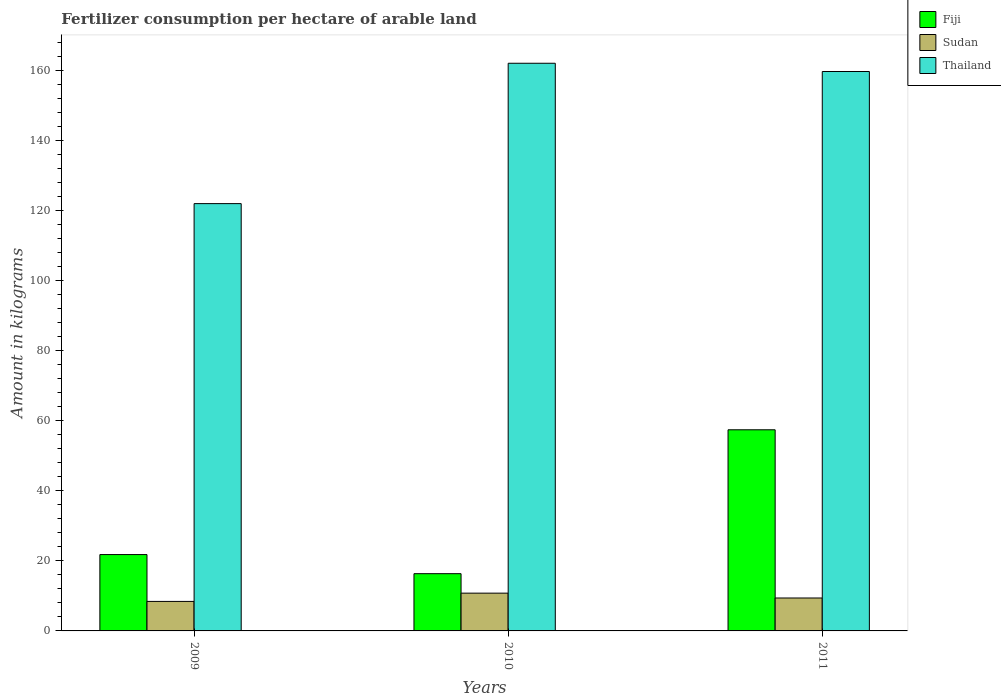How many different coloured bars are there?
Ensure brevity in your answer.  3. How many bars are there on the 3rd tick from the left?
Offer a terse response. 3. How many bars are there on the 3rd tick from the right?
Keep it short and to the point. 3. What is the amount of fertilizer consumption in Thailand in 2009?
Your response must be concise. 122.06. Across all years, what is the maximum amount of fertilizer consumption in Fiji?
Ensure brevity in your answer.  57.45. Across all years, what is the minimum amount of fertilizer consumption in Thailand?
Ensure brevity in your answer.  122.06. In which year was the amount of fertilizer consumption in Sudan minimum?
Give a very brief answer. 2009. What is the total amount of fertilizer consumption in Fiji in the graph?
Provide a succinct answer. 95.61. What is the difference between the amount of fertilizer consumption in Fiji in 2009 and that in 2010?
Offer a very short reply. 5.46. What is the difference between the amount of fertilizer consumption in Thailand in 2011 and the amount of fertilizer consumption in Sudan in 2009?
Offer a very short reply. 151.37. What is the average amount of fertilizer consumption in Thailand per year?
Make the answer very short. 148. In the year 2011, what is the difference between the amount of fertilizer consumption in Fiji and amount of fertilizer consumption in Thailand?
Keep it short and to the point. -102.35. In how many years, is the amount of fertilizer consumption in Fiji greater than 36 kg?
Ensure brevity in your answer.  1. What is the ratio of the amount of fertilizer consumption in Fiji in 2010 to that in 2011?
Give a very brief answer. 0.28. Is the amount of fertilizer consumption in Thailand in 2009 less than that in 2010?
Your answer should be compact. Yes. What is the difference between the highest and the second highest amount of fertilizer consumption in Thailand?
Your response must be concise. 2.36. What is the difference between the highest and the lowest amount of fertilizer consumption in Sudan?
Your answer should be compact. 2.36. What does the 2nd bar from the left in 2010 represents?
Offer a very short reply. Sudan. What does the 2nd bar from the right in 2009 represents?
Offer a terse response. Sudan. How many bars are there?
Your answer should be compact. 9. Are all the bars in the graph horizontal?
Give a very brief answer. No. Are the values on the major ticks of Y-axis written in scientific E-notation?
Offer a very short reply. No. Does the graph contain any zero values?
Make the answer very short. No. Does the graph contain grids?
Provide a short and direct response. No. Where does the legend appear in the graph?
Make the answer very short. Top right. What is the title of the graph?
Offer a very short reply. Fertilizer consumption per hectare of arable land. Does "Azerbaijan" appear as one of the legend labels in the graph?
Ensure brevity in your answer.  No. What is the label or title of the X-axis?
Your answer should be very brief. Years. What is the label or title of the Y-axis?
Ensure brevity in your answer.  Amount in kilograms. What is the Amount in kilograms in Fiji in 2009?
Keep it short and to the point. 21.81. What is the Amount in kilograms in Sudan in 2009?
Ensure brevity in your answer.  8.43. What is the Amount in kilograms in Thailand in 2009?
Provide a succinct answer. 122.06. What is the Amount in kilograms in Fiji in 2010?
Keep it short and to the point. 16.35. What is the Amount in kilograms of Sudan in 2010?
Give a very brief answer. 10.79. What is the Amount in kilograms of Thailand in 2010?
Keep it short and to the point. 162.16. What is the Amount in kilograms of Fiji in 2011?
Offer a very short reply. 57.45. What is the Amount in kilograms in Sudan in 2011?
Give a very brief answer. 9.41. What is the Amount in kilograms of Thailand in 2011?
Make the answer very short. 159.8. Across all years, what is the maximum Amount in kilograms in Fiji?
Provide a short and direct response. 57.45. Across all years, what is the maximum Amount in kilograms of Sudan?
Ensure brevity in your answer.  10.79. Across all years, what is the maximum Amount in kilograms in Thailand?
Your answer should be very brief. 162.16. Across all years, what is the minimum Amount in kilograms of Fiji?
Ensure brevity in your answer.  16.35. Across all years, what is the minimum Amount in kilograms of Sudan?
Keep it short and to the point. 8.43. Across all years, what is the minimum Amount in kilograms of Thailand?
Offer a terse response. 122.06. What is the total Amount in kilograms of Fiji in the graph?
Provide a succinct answer. 95.61. What is the total Amount in kilograms of Sudan in the graph?
Offer a terse response. 28.63. What is the total Amount in kilograms of Thailand in the graph?
Your answer should be very brief. 444.01. What is the difference between the Amount in kilograms in Fiji in 2009 and that in 2010?
Give a very brief answer. 5.46. What is the difference between the Amount in kilograms of Sudan in 2009 and that in 2010?
Keep it short and to the point. -2.36. What is the difference between the Amount in kilograms of Thailand in 2009 and that in 2010?
Give a very brief answer. -40.1. What is the difference between the Amount in kilograms in Fiji in 2009 and that in 2011?
Ensure brevity in your answer.  -35.65. What is the difference between the Amount in kilograms of Sudan in 2009 and that in 2011?
Keep it short and to the point. -0.98. What is the difference between the Amount in kilograms of Thailand in 2009 and that in 2011?
Give a very brief answer. -37.74. What is the difference between the Amount in kilograms in Fiji in 2010 and that in 2011?
Ensure brevity in your answer.  -41.1. What is the difference between the Amount in kilograms of Sudan in 2010 and that in 2011?
Offer a terse response. 1.38. What is the difference between the Amount in kilograms of Thailand in 2010 and that in 2011?
Give a very brief answer. 2.36. What is the difference between the Amount in kilograms of Fiji in 2009 and the Amount in kilograms of Sudan in 2010?
Your answer should be compact. 11.02. What is the difference between the Amount in kilograms of Fiji in 2009 and the Amount in kilograms of Thailand in 2010?
Offer a terse response. -140.35. What is the difference between the Amount in kilograms in Sudan in 2009 and the Amount in kilograms in Thailand in 2010?
Keep it short and to the point. -153.72. What is the difference between the Amount in kilograms of Fiji in 2009 and the Amount in kilograms of Sudan in 2011?
Your answer should be very brief. 12.4. What is the difference between the Amount in kilograms in Fiji in 2009 and the Amount in kilograms in Thailand in 2011?
Provide a short and direct response. -137.99. What is the difference between the Amount in kilograms in Sudan in 2009 and the Amount in kilograms in Thailand in 2011?
Your answer should be very brief. -151.37. What is the difference between the Amount in kilograms of Fiji in 2010 and the Amount in kilograms of Sudan in 2011?
Your answer should be very brief. 6.94. What is the difference between the Amount in kilograms in Fiji in 2010 and the Amount in kilograms in Thailand in 2011?
Keep it short and to the point. -143.45. What is the difference between the Amount in kilograms of Sudan in 2010 and the Amount in kilograms of Thailand in 2011?
Offer a very short reply. -149.01. What is the average Amount in kilograms of Fiji per year?
Offer a terse response. 31.87. What is the average Amount in kilograms in Sudan per year?
Ensure brevity in your answer.  9.54. What is the average Amount in kilograms of Thailand per year?
Keep it short and to the point. 148. In the year 2009, what is the difference between the Amount in kilograms of Fiji and Amount in kilograms of Sudan?
Keep it short and to the point. 13.38. In the year 2009, what is the difference between the Amount in kilograms in Fiji and Amount in kilograms in Thailand?
Provide a short and direct response. -100.25. In the year 2009, what is the difference between the Amount in kilograms of Sudan and Amount in kilograms of Thailand?
Your response must be concise. -113.63. In the year 2010, what is the difference between the Amount in kilograms in Fiji and Amount in kilograms in Sudan?
Offer a very short reply. 5.56. In the year 2010, what is the difference between the Amount in kilograms of Fiji and Amount in kilograms of Thailand?
Your answer should be compact. -145.8. In the year 2010, what is the difference between the Amount in kilograms of Sudan and Amount in kilograms of Thailand?
Make the answer very short. -151.36. In the year 2011, what is the difference between the Amount in kilograms of Fiji and Amount in kilograms of Sudan?
Offer a terse response. 48.05. In the year 2011, what is the difference between the Amount in kilograms of Fiji and Amount in kilograms of Thailand?
Provide a succinct answer. -102.35. In the year 2011, what is the difference between the Amount in kilograms in Sudan and Amount in kilograms in Thailand?
Give a very brief answer. -150.39. What is the ratio of the Amount in kilograms of Fiji in 2009 to that in 2010?
Your response must be concise. 1.33. What is the ratio of the Amount in kilograms of Sudan in 2009 to that in 2010?
Give a very brief answer. 0.78. What is the ratio of the Amount in kilograms of Thailand in 2009 to that in 2010?
Ensure brevity in your answer.  0.75. What is the ratio of the Amount in kilograms in Fiji in 2009 to that in 2011?
Ensure brevity in your answer.  0.38. What is the ratio of the Amount in kilograms of Sudan in 2009 to that in 2011?
Make the answer very short. 0.9. What is the ratio of the Amount in kilograms of Thailand in 2009 to that in 2011?
Keep it short and to the point. 0.76. What is the ratio of the Amount in kilograms of Fiji in 2010 to that in 2011?
Your response must be concise. 0.28. What is the ratio of the Amount in kilograms of Sudan in 2010 to that in 2011?
Your answer should be very brief. 1.15. What is the ratio of the Amount in kilograms in Thailand in 2010 to that in 2011?
Provide a succinct answer. 1.01. What is the difference between the highest and the second highest Amount in kilograms in Fiji?
Your answer should be very brief. 35.65. What is the difference between the highest and the second highest Amount in kilograms in Sudan?
Offer a very short reply. 1.38. What is the difference between the highest and the second highest Amount in kilograms in Thailand?
Offer a terse response. 2.36. What is the difference between the highest and the lowest Amount in kilograms of Fiji?
Provide a succinct answer. 41.1. What is the difference between the highest and the lowest Amount in kilograms in Sudan?
Provide a succinct answer. 2.36. What is the difference between the highest and the lowest Amount in kilograms in Thailand?
Your answer should be compact. 40.1. 